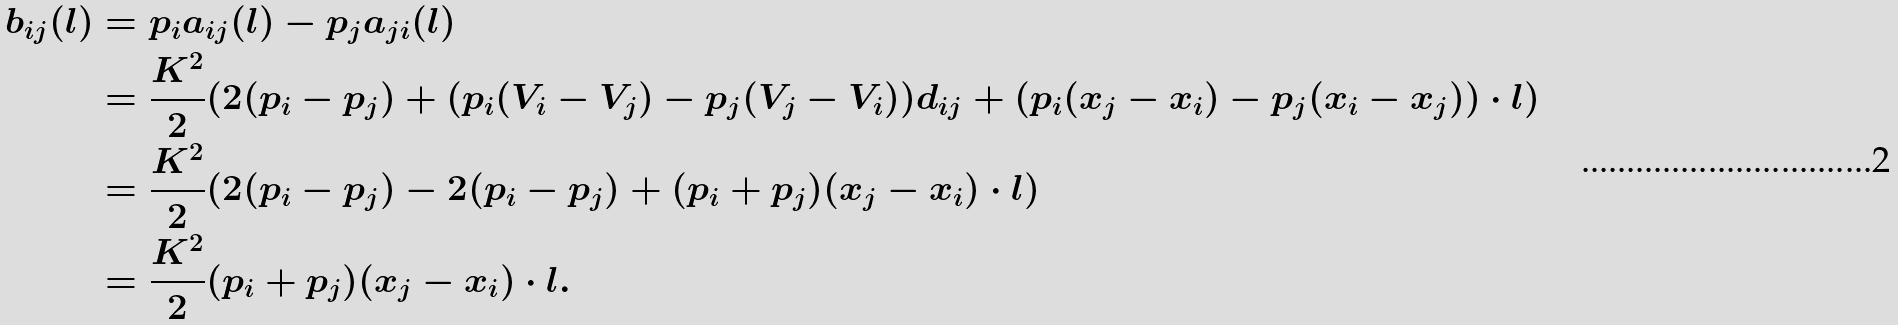Convert formula to latex. <formula><loc_0><loc_0><loc_500><loc_500>b _ { i j } ( l ) & = p _ { i } a _ { i j } ( l ) - p _ { j } a _ { j i } ( l ) \\ & = \frac { K ^ { 2 } } 2 ( 2 ( p _ { i } - p _ { j } ) + ( p _ { i } ( V _ { i } - V _ { j } ) - p _ { j } ( V _ { j } - V _ { i } ) ) d _ { i j } + ( p _ { i } ( x _ { j } - x _ { i } ) - p _ { j } ( x _ { i } - x _ { j } ) ) \cdot l ) \\ & = \frac { K ^ { 2 } } 2 ( 2 ( p _ { i } - p _ { j } ) - 2 ( p _ { i } - p _ { j } ) + ( p _ { i } + p _ { j } ) ( x _ { j } - x _ { i } ) \cdot l ) \\ & = \frac { K ^ { 2 } } 2 ( p _ { i } + p _ { j } ) ( x _ { j } - x _ { i } ) \cdot l .</formula> 